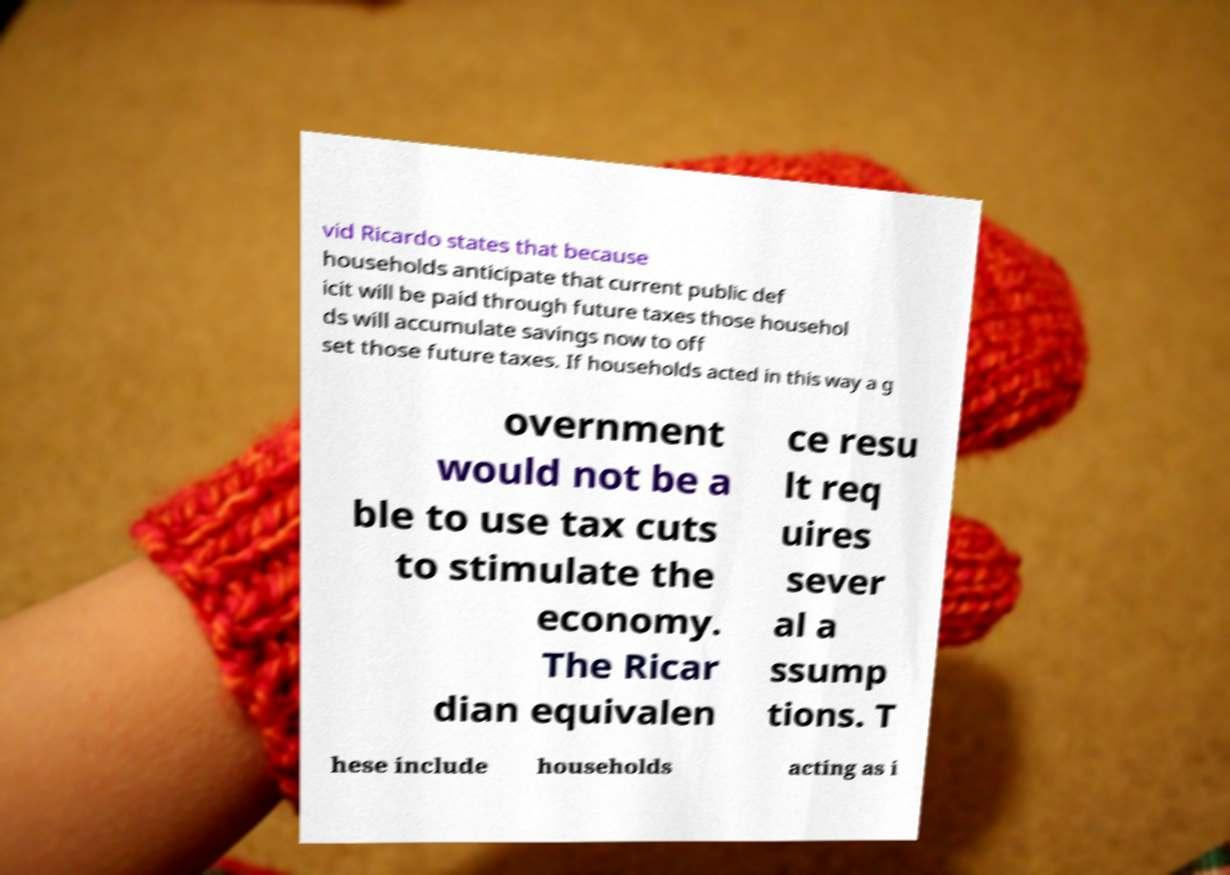Could you extract and type out the text from this image? vid Ricardo states that because households anticipate that current public def icit will be paid through future taxes those househol ds will accumulate savings now to off set those future taxes. If households acted in this way a g overnment would not be a ble to use tax cuts to stimulate the economy. The Ricar dian equivalen ce resu lt req uires sever al a ssump tions. T hese include households acting as i 